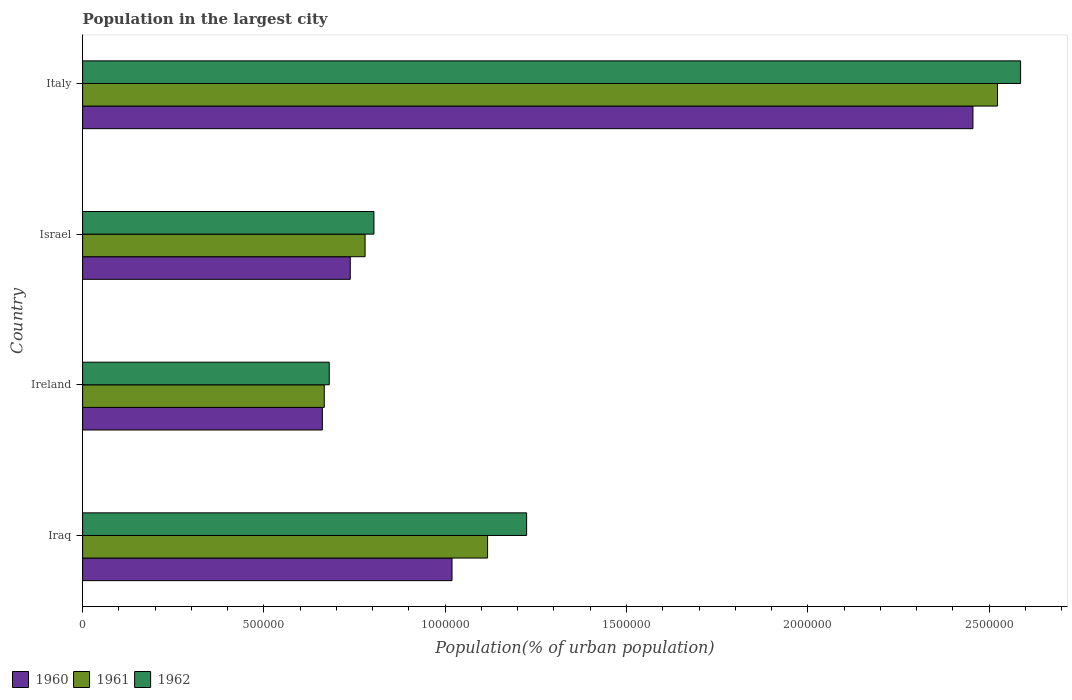How many different coloured bars are there?
Offer a very short reply. 3. How many groups of bars are there?
Keep it short and to the point. 4. Are the number of bars per tick equal to the number of legend labels?
Your response must be concise. Yes. Are the number of bars on each tick of the Y-axis equal?
Provide a short and direct response. Yes. How many bars are there on the 2nd tick from the top?
Give a very brief answer. 3. How many bars are there on the 4th tick from the bottom?
Ensure brevity in your answer.  3. What is the population in the largest city in 1962 in Ireland?
Offer a terse response. 6.80e+05. Across all countries, what is the maximum population in the largest city in 1962?
Your answer should be very brief. 2.59e+06. Across all countries, what is the minimum population in the largest city in 1962?
Offer a terse response. 6.80e+05. In which country was the population in the largest city in 1961 minimum?
Give a very brief answer. Ireland. What is the total population in the largest city in 1961 in the graph?
Keep it short and to the point. 5.09e+06. What is the difference between the population in the largest city in 1962 in Ireland and that in Israel?
Keep it short and to the point. -1.23e+05. What is the difference between the population in the largest city in 1960 in Israel and the population in the largest city in 1962 in Iraq?
Make the answer very short. -4.86e+05. What is the average population in the largest city in 1960 per country?
Ensure brevity in your answer.  1.22e+06. What is the difference between the population in the largest city in 1960 and population in the largest city in 1961 in Israel?
Offer a terse response. -4.09e+04. In how many countries, is the population in the largest city in 1960 greater than 2000000 %?
Provide a succinct answer. 1. What is the ratio of the population in the largest city in 1962 in Ireland to that in Israel?
Your answer should be compact. 0.85. Is the difference between the population in the largest city in 1960 in Iraq and Ireland greater than the difference between the population in the largest city in 1961 in Iraq and Ireland?
Offer a terse response. No. What is the difference between the highest and the second highest population in the largest city in 1960?
Make the answer very short. 1.44e+06. What is the difference between the highest and the lowest population in the largest city in 1962?
Offer a very short reply. 1.91e+06. In how many countries, is the population in the largest city in 1962 greater than the average population in the largest city in 1962 taken over all countries?
Keep it short and to the point. 1. Is it the case that in every country, the sum of the population in the largest city in 1960 and population in the largest city in 1961 is greater than the population in the largest city in 1962?
Offer a terse response. Yes. Are all the bars in the graph horizontal?
Give a very brief answer. Yes. How many countries are there in the graph?
Offer a terse response. 4. Does the graph contain grids?
Provide a succinct answer. No. Where does the legend appear in the graph?
Your answer should be very brief. Bottom left. How many legend labels are there?
Your answer should be very brief. 3. How are the legend labels stacked?
Your answer should be very brief. Horizontal. What is the title of the graph?
Offer a terse response. Population in the largest city. What is the label or title of the X-axis?
Offer a very short reply. Population(% of urban population). What is the label or title of the Y-axis?
Your answer should be compact. Country. What is the Population(% of urban population) in 1960 in Iraq?
Your response must be concise. 1.02e+06. What is the Population(% of urban population) in 1961 in Iraq?
Ensure brevity in your answer.  1.12e+06. What is the Population(% of urban population) in 1962 in Iraq?
Offer a very short reply. 1.22e+06. What is the Population(% of urban population) in 1960 in Ireland?
Offer a very short reply. 6.61e+05. What is the Population(% of urban population) of 1961 in Ireland?
Your response must be concise. 6.66e+05. What is the Population(% of urban population) in 1962 in Ireland?
Provide a succinct answer. 6.80e+05. What is the Population(% of urban population) of 1960 in Israel?
Make the answer very short. 7.38e+05. What is the Population(% of urban population) of 1961 in Israel?
Keep it short and to the point. 7.79e+05. What is the Population(% of urban population) in 1962 in Israel?
Your answer should be compact. 8.04e+05. What is the Population(% of urban population) in 1960 in Italy?
Ensure brevity in your answer.  2.46e+06. What is the Population(% of urban population) in 1961 in Italy?
Keep it short and to the point. 2.52e+06. What is the Population(% of urban population) in 1962 in Italy?
Give a very brief answer. 2.59e+06. Across all countries, what is the maximum Population(% of urban population) of 1960?
Ensure brevity in your answer.  2.46e+06. Across all countries, what is the maximum Population(% of urban population) of 1961?
Offer a very short reply. 2.52e+06. Across all countries, what is the maximum Population(% of urban population) of 1962?
Your answer should be compact. 2.59e+06. Across all countries, what is the minimum Population(% of urban population) in 1960?
Offer a terse response. 6.61e+05. Across all countries, what is the minimum Population(% of urban population) in 1961?
Give a very brief answer. 6.66e+05. Across all countries, what is the minimum Population(% of urban population) of 1962?
Your answer should be compact. 6.80e+05. What is the total Population(% of urban population) in 1960 in the graph?
Your answer should be very brief. 4.87e+06. What is the total Population(% of urban population) of 1961 in the graph?
Provide a short and direct response. 5.09e+06. What is the total Population(% of urban population) in 1962 in the graph?
Offer a very short reply. 5.30e+06. What is the difference between the Population(% of urban population) of 1960 in Iraq and that in Ireland?
Provide a succinct answer. 3.58e+05. What is the difference between the Population(% of urban population) in 1961 in Iraq and that in Ireland?
Offer a very short reply. 4.50e+05. What is the difference between the Population(% of urban population) of 1962 in Iraq and that in Ireland?
Your answer should be compact. 5.44e+05. What is the difference between the Population(% of urban population) in 1960 in Iraq and that in Israel?
Offer a very short reply. 2.81e+05. What is the difference between the Population(% of urban population) of 1961 in Iraq and that in Israel?
Offer a very short reply. 3.38e+05. What is the difference between the Population(% of urban population) in 1962 in Iraq and that in Israel?
Ensure brevity in your answer.  4.21e+05. What is the difference between the Population(% of urban population) of 1960 in Iraq and that in Italy?
Ensure brevity in your answer.  -1.44e+06. What is the difference between the Population(% of urban population) in 1961 in Iraq and that in Italy?
Keep it short and to the point. -1.41e+06. What is the difference between the Population(% of urban population) in 1962 in Iraq and that in Italy?
Provide a succinct answer. -1.36e+06. What is the difference between the Population(% of urban population) in 1960 in Ireland and that in Israel?
Make the answer very short. -7.70e+04. What is the difference between the Population(% of urban population) in 1961 in Ireland and that in Israel?
Keep it short and to the point. -1.13e+05. What is the difference between the Population(% of urban population) in 1962 in Ireland and that in Israel?
Provide a succinct answer. -1.23e+05. What is the difference between the Population(% of urban population) in 1960 in Ireland and that in Italy?
Your answer should be very brief. -1.79e+06. What is the difference between the Population(% of urban population) of 1961 in Ireland and that in Italy?
Give a very brief answer. -1.86e+06. What is the difference between the Population(% of urban population) of 1962 in Ireland and that in Italy?
Offer a very short reply. -1.91e+06. What is the difference between the Population(% of urban population) in 1960 in Israel and that in Italy?
Keep it short and to the point. -1.72e+06. What is the difference between the Population(% of urban population) in 1961 in Israel and that in Italy?
Your response must be concise. -1.74e+06. What is the difference between the Population(% of urban population) in 1962 in Israel and that in Italy?
Offer a very short reply. -1.78e+06. What is the difference between the Population(% of urban population) of 1960 in Iraq and the Population(% of urban population) of 1961 in Ireland?
Your answer should be compact. 3.52e+05. What is the difference between the Population(% of urban population) of 1960 in Iraq and the Population(% of urban population) of 1962 in Ireland?
Your answer should be very brief. 3.39e+05. What is the difference between the Population(% of urban population) of 1961 in Iraq and the Population(% of urban population) of 1962 in Ireland?
Make the answer very short. 4.37e+05. What is the difference between the Population(% of urban population) of 1960 in Iraq and the Population(% of urban population) of 1961 in Israel?
Make the answer very short. 2.40e+05. What is the difference between the Population(% of urban population) in 1960 in Iraq and the Population(% of urban population) in 1962 in Israel?
Offer a very short reply. 2.15e+05. What is the difference between the Population(% of urban population) of 1961 in Iraq and the Population(% of urban population) of 1962 in Israel?
Ensure brevity in your answer.  3.13e+05. What is the difference between the Population(% of urban population) of 1960 in Iraq and the Population(% of urban population) of 1961 in Italy?
Your answer should be compact. -1.50e+06. What is the difference between the Population(% of urban population) in 1960 in Iraq and the Population(% of urban population) in 1962 in Italy?
Your answer should be very brief. -1.57e+06. What is the difference between the Population(% of urban population) in 1961 in Iraq and the Population(% of urban population) in 1962 in Italy?
Make the answer very short. -1.47e+06. What is the difference between the Population(% of urban population) in 1960 in Ireland and the Population(% of urban population) in 1961 in Israel?
Your answer should be compact. -1.18e+05. What is the difference between the Population(% of urban population) of 1960 in Ireland and the Population(% of urban population) of 1962 in Israel?
Provide a short and direct response. -1.42e+05. What is the difference between the Population(% of urban population) of 1961 in Ireland and the Population(% of urban population) of 1962 in Israel?
Ensure brevity in your answer.  -1.37e+05. What is the difference between the Population(% of urban population) of 1960 in Ireland and the Population(% of urban population) of 1961 in Italy?
Offer a very short reply. -1.86e+06. What is the difference between the Population(% of urban population) in 1960 in Ireland and the Population(% of urban population) in 1962 in Italy?
Provide a succinct answer. -1.93e+06. What is the difference between the Population(% of urban population) in 1961 in Ireland and the Population(% of urban population) in 1962 in Italy?
Your answer should be compact. -1.92e+06. What is the difference between the Population(% of urban population) in 1960 in Israel and the Population(% of urban population) in 1961 in Italy?
Offer a terse response. -1.79e+06. What is the difference between the Population(% of urban population) of 1960 in Israel and the Population(% of urban population) of 1962 in Italy?
Ensure brevity in your answer.  -1.85e+06. What is the difference between the Population(% of urban population) of 1961 in Israel and the Population(% of urban population) of 1962 in Italy?
Make the answer very short. -1.81e+06. What is the average Population(% of urban population) of 1960 per country?
Make the answer very short. 1.22e+06. What is the average Population(% of urban population) in 1961 per country?
Ensure brevity in your answer.  1.27e+06. What is the average Population(% of urban population) of 1962 per country?
Provide a succinct answer. 1.32e+06. What is the difference between the Population(% of urban population) in 1960 and Population(% of urban population) in 1961 in Iraq?
Give a very brief answer. -9.81e+04. What is the difference between the Population(% of urban population) of 1960 and Population(% of urban population) of 1962 in Iraq?
Offer a terse response. -2.06e+05. What is the difference between the Population(% of urban population) in 1961 and Population(% of urban population) in 1962 in Iraq?
Your answer should be very brief. -1.08e+05. What is the difference between the Population(% of urban population) of 1960 and Population(% of urban population) of 1961 in Ireland?
Offer a terse response. -5272. What is the difference between the Population(% of urban population) of 1960 and Population(% of urban population) of 1962 in Ireland?
Offer a very short reply. -1.90e+04. What is the difference between the Population(% of urban population) in 1961 and Population(% of urban population) in 1962 in Ireland?
Ensure brevity in your answer.  -1.37e+04. What is the difference between the Population(% of urban population) of 1960 and Population(% of urban population) of 1961 in Israel?
Offer a very short reply. -4.09e+04. What is the difference between the Population(% of urban population) in 1960 and Population(% of urban population) in 1962 in Israel?
Keep it short and to the point. -6.54e+04. What is the difference between the Population(% of urban population) in 1961 and Population(% of urban population) in 1962 in Israel?
Offer a very short reply. -2.45e+04. What is the difference between the Population(% of urban population) in 1960 and Population(% of urban population) in 1961 in Italy?
Give a very brief answer. -6.77e+04. What is the difference between the Population(% of urban population) of 1960 and Population(% of urban population) of 1962 in Italy?
Provide a short and direct response. -1.31e+05. What is the difference between the Population(% of urban population) of 1961 and Population(% of urban population) of 1962 in Italy?
Your response must be concise. -6.37e+04. What is the ratio of the Population(% of urban population) of 1960 in Iraq to that in Ireland?
Offer a terse response. 1.54. What is the ratio of the Population(% of urban population) of 1961 in Iraq to that in Ireland?
Offer a terse response. 1.68. What is the ratio of the Population(% of urban population) in 1962 in Iraq to that in Ireland?
Offer a terse response. 1.8. What is the ratio of the Population(% of urban population) in 1960 in Iraq to that in Israel?
Keep it short and to the point. 1.38. What is the ratio of the Population(% of urban population) in 1961 in Iraq to that in Israel?
Make the answer very short. 1.43. What is the ratio of the Population(% of urban population) in 1962 in Iraq to that in Israel?
Provide a succinct answer. 1.52. What is the ratio of the Population(% of urban population) in 1960 in Iraq to that in Italy?
Give a very brief answer. 0.41. What is the ratio of the Population(% of urban population) in 1961 in Iraq to that in Italy?
Give a very brief answer. 0.44. What is the ratio of the Population(% of urban population) of 1962 in Iraq to that in Italy?
Offer a very short reply. 0.47. What is the ratio of the Population(% of urban population) of 1960 in Ireland to that in Israel?
Your answer should be very brief. 0.9. What is the ratio of the Population(% of urban population) of 1961 in Ireland to that in Israel?
Your answer should be very brief. 0.86. What is the ratio of the Population(% of urban population) in 1962 in Ireland to that in Israel?
Ensure brevity in your answer.  0.85. What is the ratio of the Population(% of urban population) in 1960 in Ireland to that in Italy?
Keep it short and to the point. 0.27. What is the ratio of the Population(% of urban population) in 1961 in Ireland to that in Italy?
Provide a succinct answer. 0.26. What is the ratio of the Population(% of urban population) of 1962 in Ireland to that in Italy?
Make the answer very short. 0.26. What is the ratio of the Population(% of urban population) in 1960 in Israel to that in Italy?
Offer a terse response. 0.3. What is the ratio of the Population(% of urban population) in 1961 in Israel to that in Italy?
Keep it short and to the point. 0.31. What is the ratio of the Population(% of urban population) of 1962 in Israel to that in Italy?
Provide a short and direct response. 0.31. What is the difference between the highest and the second highest Population(% of urban population) in 1960?
Ensure brevity in your answer.  1.44e+06. What is the difference between the highest and the second highest Population(% of urban population) of 1961?
Offer a terse response. 1.41e+06. What is the difference between the highest and the second highest Population(% of urban population) in 1962?
Make the answer very short. 1.36e+06. What is the difference between the highest and the lowest Population(% of urban population) of 1960?
Your answer should be very brief. 1.79e+06. What is the difference between the highest and the lowest Population(% of urban population) in 1961?
Provide a succinct answer. 1.86e+06. What is the difference between the highest and the lowest Population(% of urban population) of 1962?
Ensure brevity in your answer.  1.91e+06. 